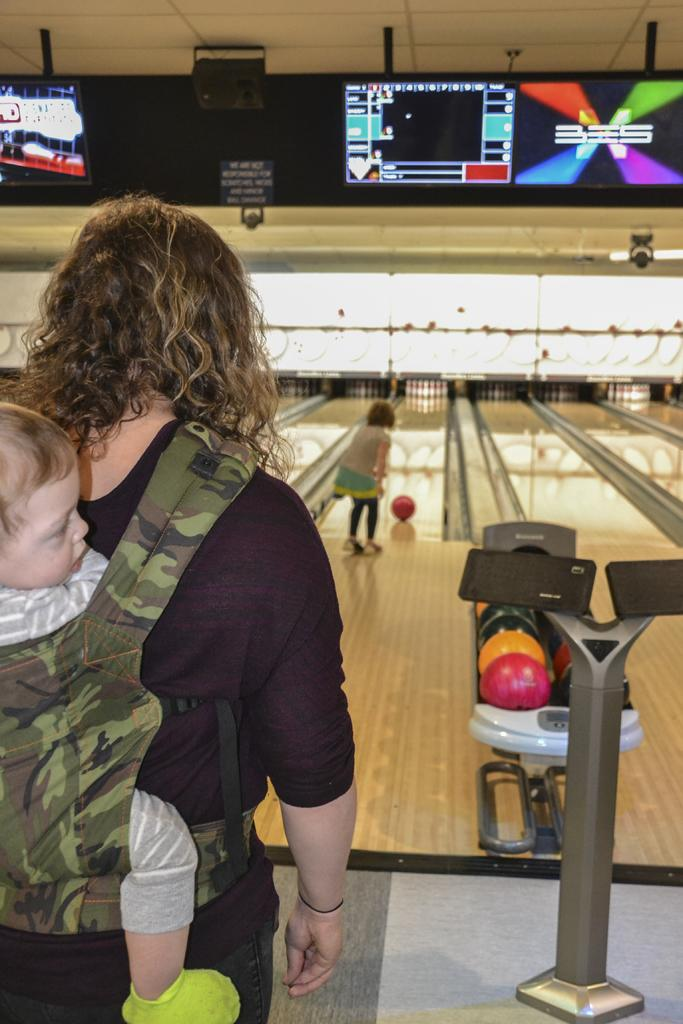What objects are present in the image? There are balls in the image, which represent a game. Can you describe the game in the image? The image represents a game, but specific details about the game are not provided. What is located at the top of the image? There is a screen at the top of the image. Who is present in the image? There is a woman in the image, and she is carrying a baby. What type of drum can be seen in the image? There is no drum present in the image. How many clovers are visible in the image? There are no clovers visible in the image. 